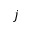<formula> <loc_0><loc_0><loc_500><loc_500>j</formula> 